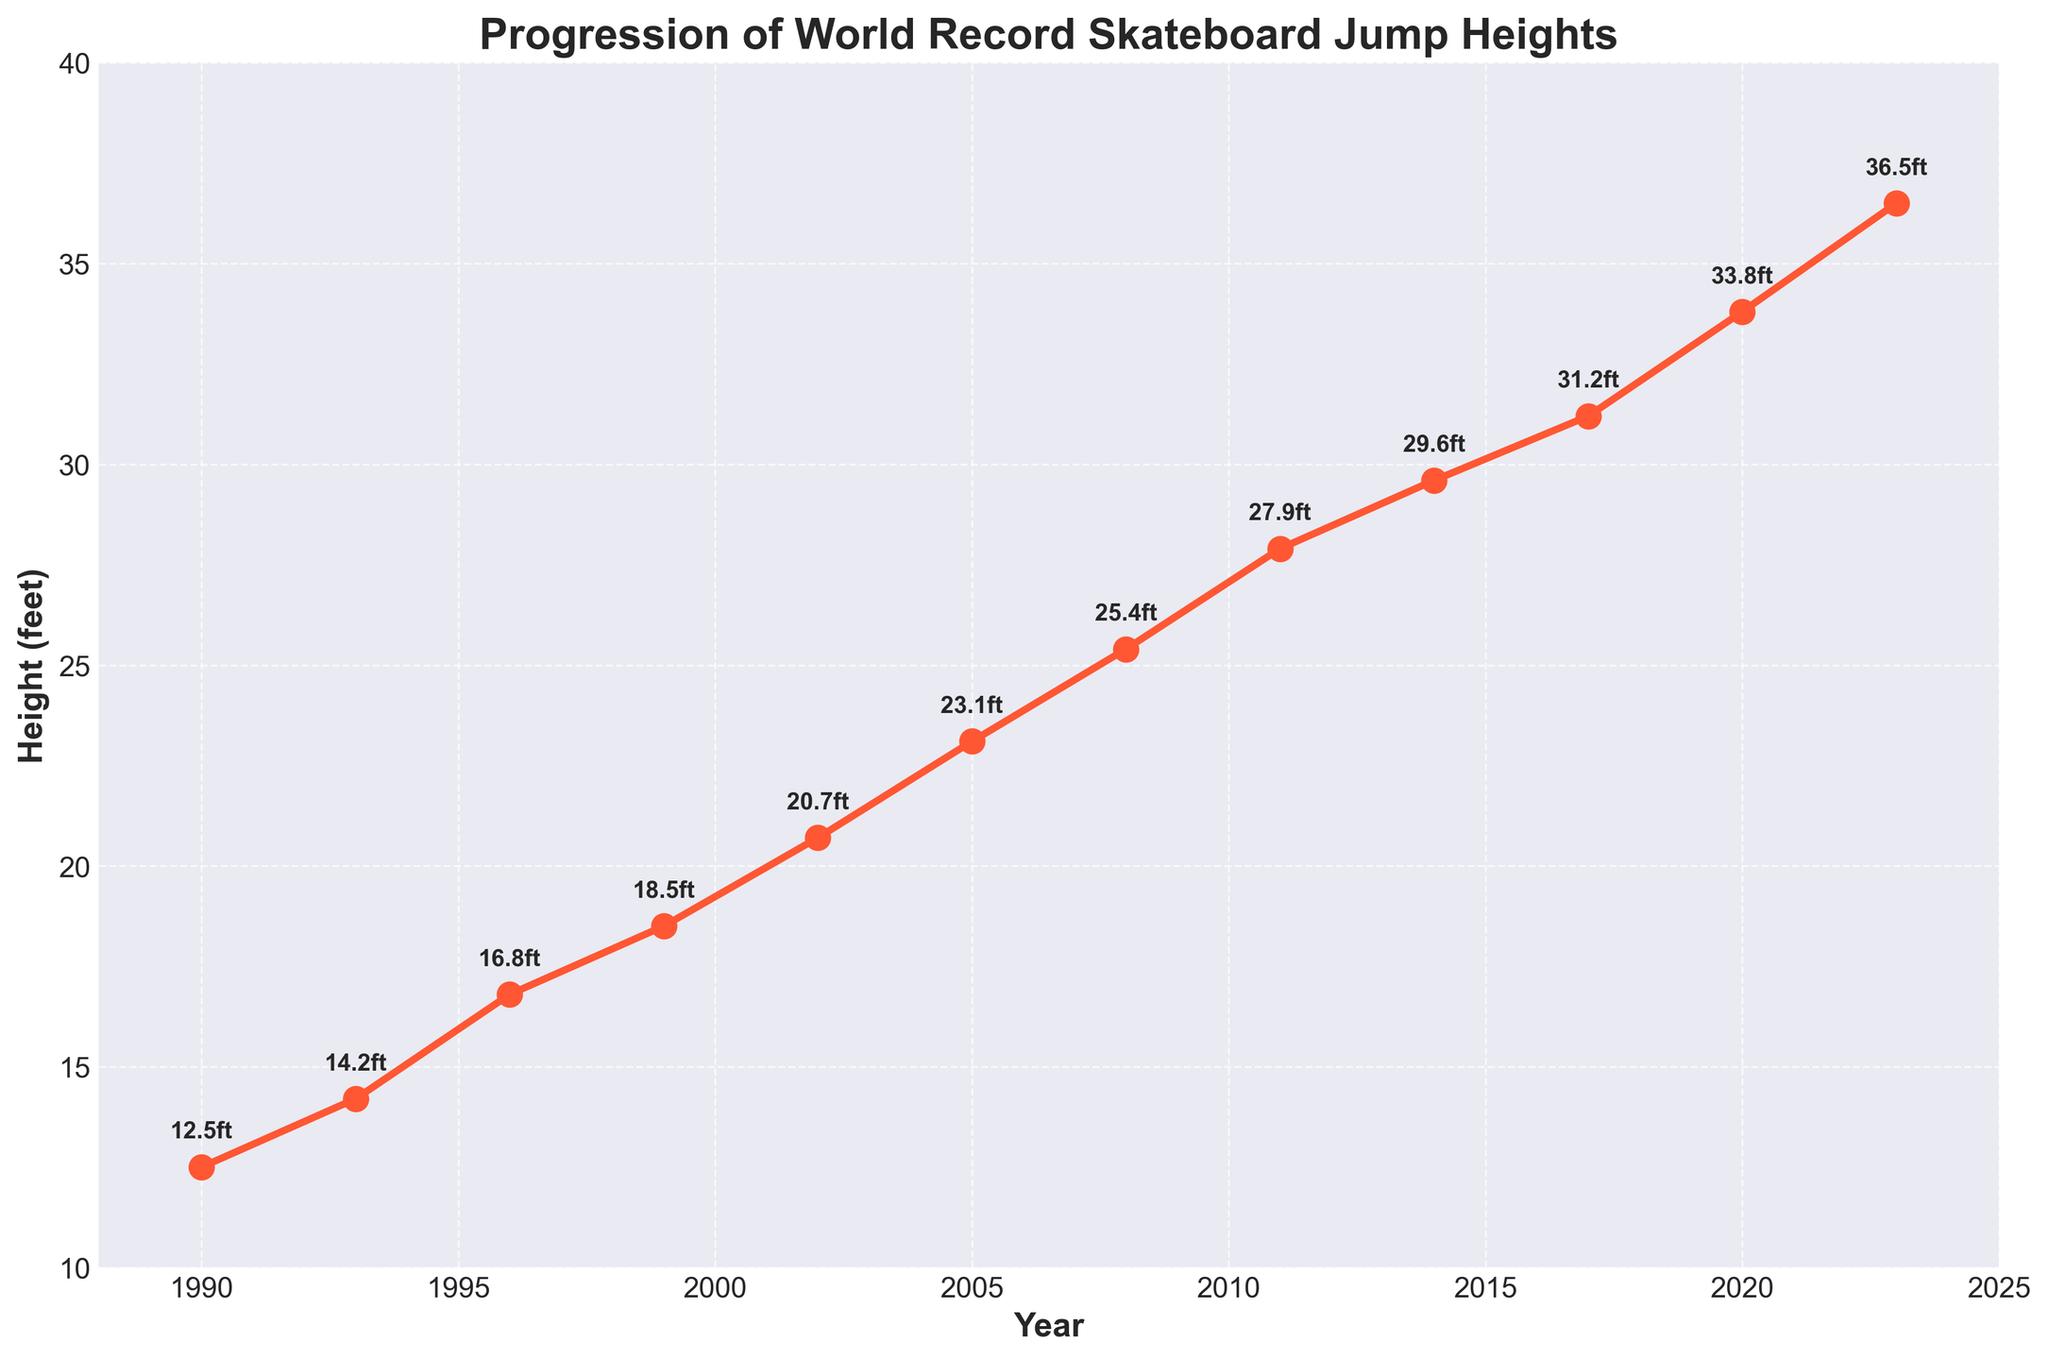What's the highest recorded skateboard jump height and in which year did it occur? The highest recorded height can be identified by finding the tallest point on the graph and checking its year label. The highest jump height is 36.5 feet, which occurred in 2023.
Answer: 36.5 feet, 2023 What is the difference between the skateboard jump heights in 2002 and 2023? Look at the height values for 2002 and 2023; subtract the 2002 value (20.7 feet) from the 2023 value (36.5 feet): 36.5 - 20.7 = 15.8 feet.
Answer: 15.8 feet How much did the jump height increase on average per year from 1990 to 2023? First, calculate the total increase in height from 1990 (12.5 feet) to 2023 (36.5 feet): 36.5 - 12.5 = 24 feet. Then, divide this increase by the number of years between 1990 and 2023 (2023 - 1990 = 33 years): 24 / 33 ≈ 0.727 feet per year.
Answer: Approximately 0.727 feet per year Which three-year period saw the greatest increase in jump heights, and what was the increase? Examine the graph and check the increases between consecutive three-year periods. The greatest increase was between 2017 and 2020: 33.8 feet - 31.2 feet = 2.6 feet.
Answer: 2017-2020, 2.6 feet What trend can be observed in the progression of world record skateboard jump heights over time? Inspect the overall direction of the line in the graph. The trend shows a clear and consistent increase in jump heights from 1990 to 2023, indicating continuous improvement and advancements.
Answer: Consistent increase Compare the skateboard jump heights in 1996 and 2014. By what percentage did the height increase? Calculate the height difference: 29.6 feet (2014) - 16.8 feet (1996) = 12.8 feet. Then, find the percentage increase relative to the 1996 height: (12.8 / 16.8) * 100 ≈ 76.19%.
Answer: Approximately 76.19% In which period did the jump height first exceed 30 feet? Identify the jump heights over 30 feet and check their corresponding years. The height first exceeded 30 feet in 2017 with a value of 31.2 feet.
Answer: 2017 What is the median skateboarding jump height recorded between 1990 and 2023? List all the recorded heights and find the middle value. With an even number of data points (12), the median is the average of the 6th and 7th values: (23.1 + 25.4) / 2 = 24.25 feet.
Answer: 24.25 feet 